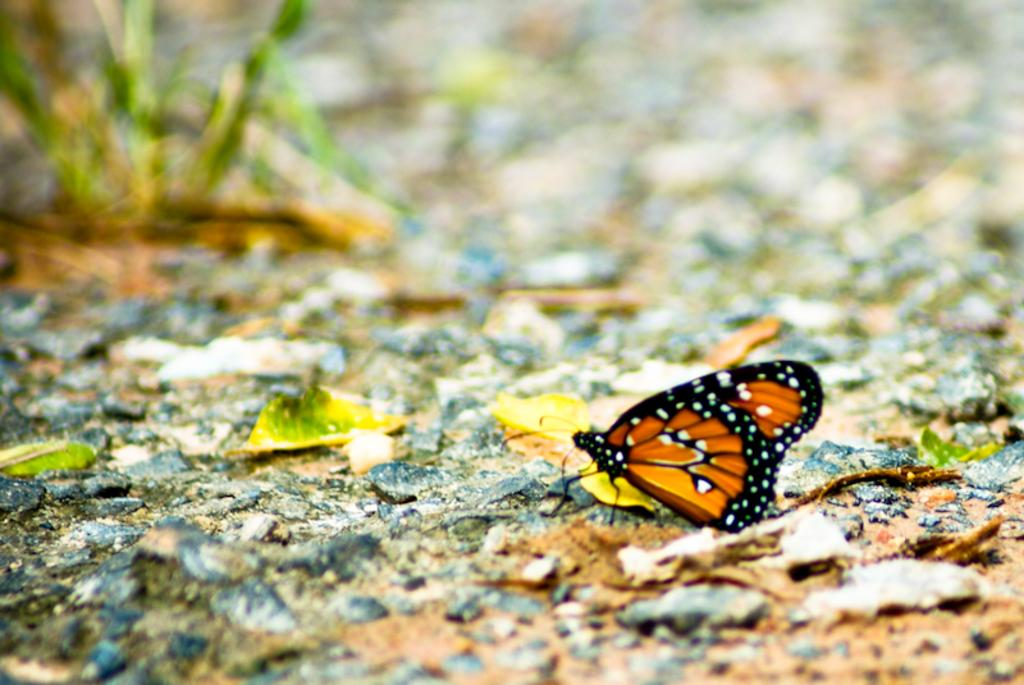What is the main subject of the image? There is a butterfly in the image. Where is the butterfly located in the image? The butterfly is on a path. Can you describe the background of the image? The background of the image is blurred. What type of machine can be seen in the cellar in the image? There is no machine or cellar present in the image; it features a butterfly on a path with a blurred background. 